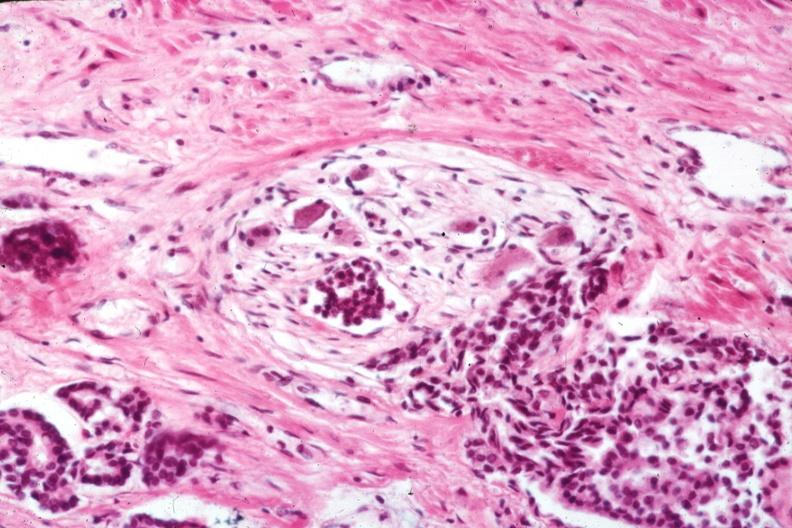what is present?
Answer the question using a single word or phrase. Adenocarcinoma 